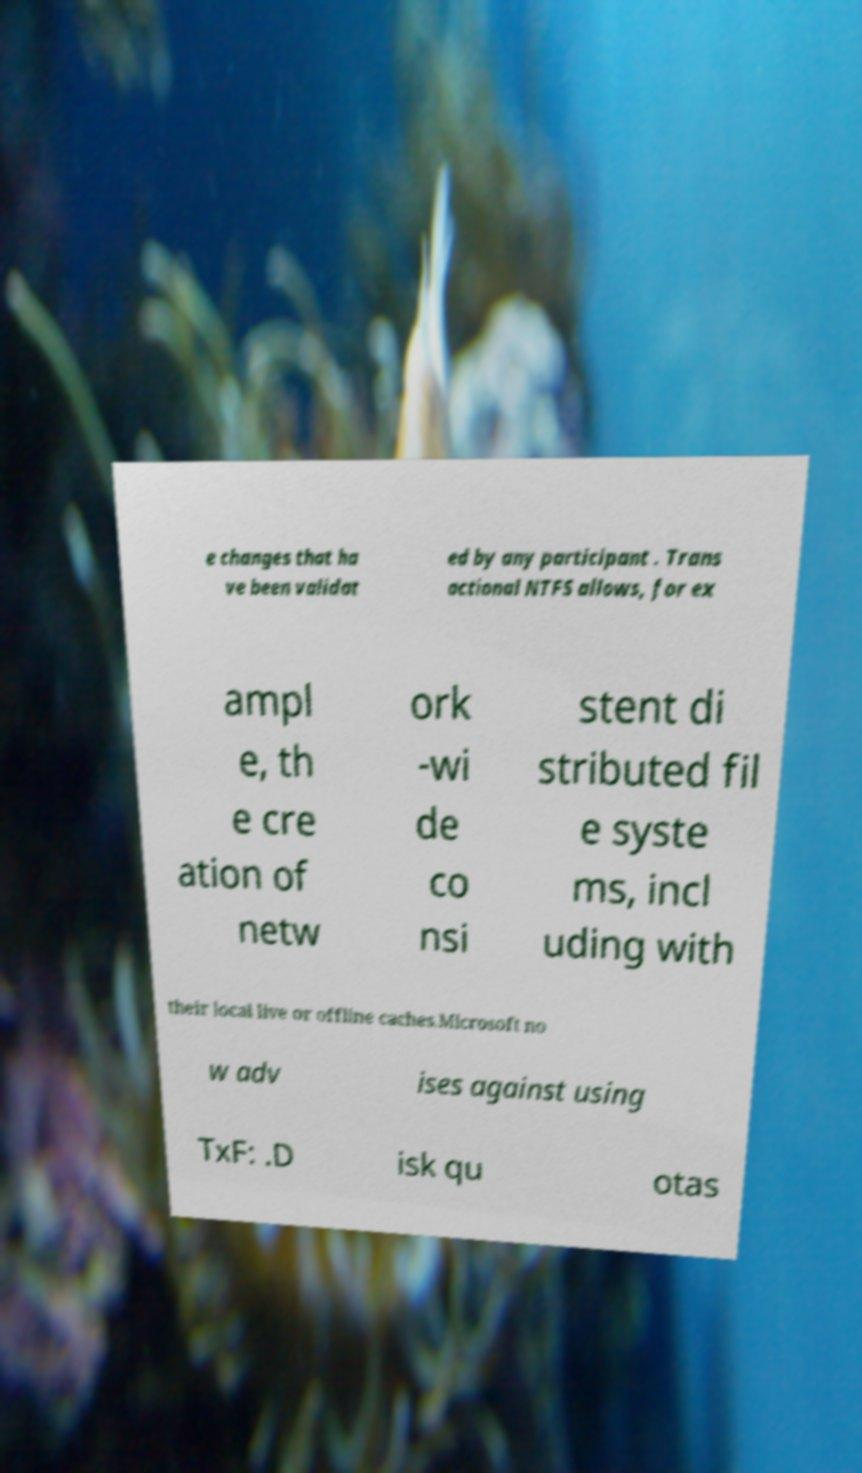Could you extract and type out the text from this image? e changes that ha ve been validat ed by any participant . Trans actional NTFS allows, for ex ampl e, th e cre ation of netw ork -wi de co nsi stent di stributed fil e syste ms, incl uding with their local live or offline caches.Microsoft no w adv ises against using TxF: .D isk qu otas 